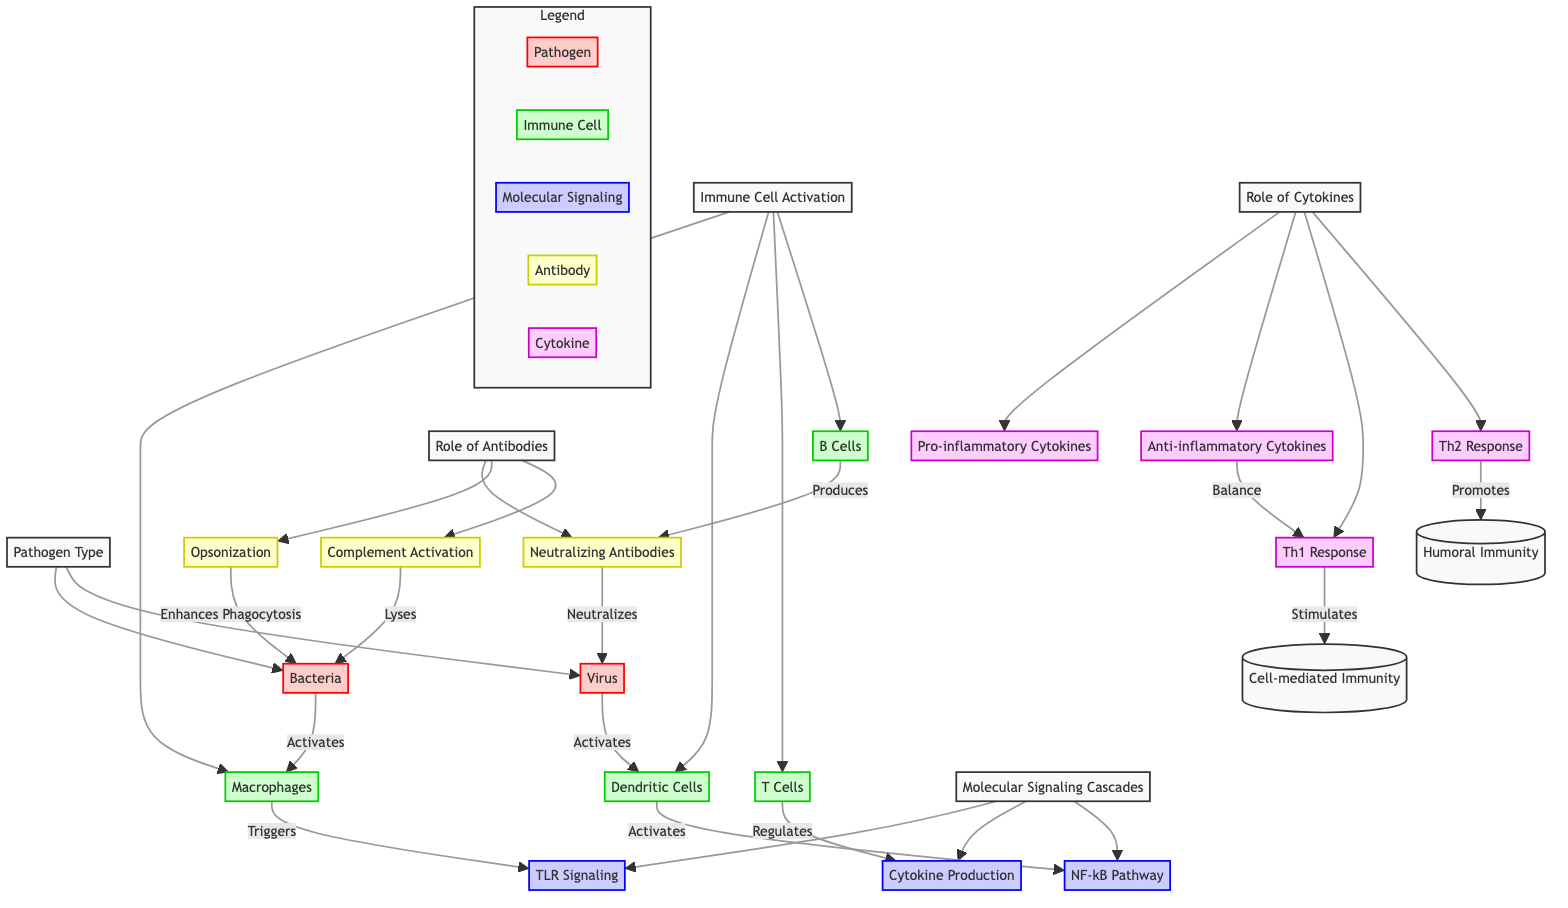What are the two types of pathogens depicted? The diagram explicitly shows "Bacteria" and "Virus" as the two types of pathogens connected to the "Pathogen Type" node.
Answer: Bacteria, Virus How many immune cell types are activated? The diagram lists four types of immune cells: Macrophages, Dendritic Cells, T Cells, and B Cells, connected under the "Immune Cell Activation" node.
Answer: Four Which immune cells are activated by bacteria? The diagram indicates that "Macrophages" are activated by bacteria, as labeled in the related connection.
Answer: Macrophages What signaling cascade is triggered by macrophages? The diagram shows that macrophages specifically trigger the "TLR Signaling" pathway, indicating their direct role in immune signaling.
Answer: TLR Signaling What response do Th1 cytokines stimulate? Referring to the diagram, Th1 response directly stimulates "Cell-mediated Immunity" as shown in the relationship between "Th1 Response" and "Cell-mediated Immunity" nodes.
Answer: Cell-mediated Immunity Which type of antibodies do B Cells produce? B Cells are shown to produce "Neutralizing Antibodies" in the diagram, establishing a clear connection between B Cells and the type of antibody involved in the immune response.
Answer: Neutralizing Antibodies What is the role of anti-inflammatory cytokines? The diagram illustrates that anti-inflammatory cytokines serve to "Balance" the Th1 response, indicating their regulatory role in the immune reaction.
Answer: Balance How do neutralizing antibodies affect viruses? According to the diagram, neutralizing antibodies "Neutralize" viruses, demonstrating their protective mechanism against viral infections.
Answer: Neutralize What are the two types of cytokine responses shown? The diagram lists two types: "Pro-inflammatory Cytokines" and "Anti-inflammatory Cytokines," both connected under the "Role of Cytokines" node.
Answer: Pro-inflammatory, Anti-inflammatory 